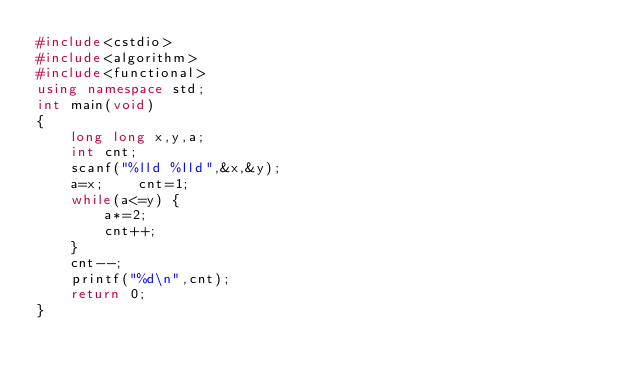<code> <loc_0><loc_0><loc_500><loc_500><_C++_>#include<cstdio>
#include<algorithm>
#include<functional>
using namespace std;
int main(void)
{
	long long x,y,a;
	int cnt;
	scanf("%lld %lld",&x,&y);
	a=x;	cnt=1;
	while(a<=y)	{
		a*=2;
		cnt++;
	}
	cnt--;
	printf("%d\n",cnt);
	return 0;
}</code> 